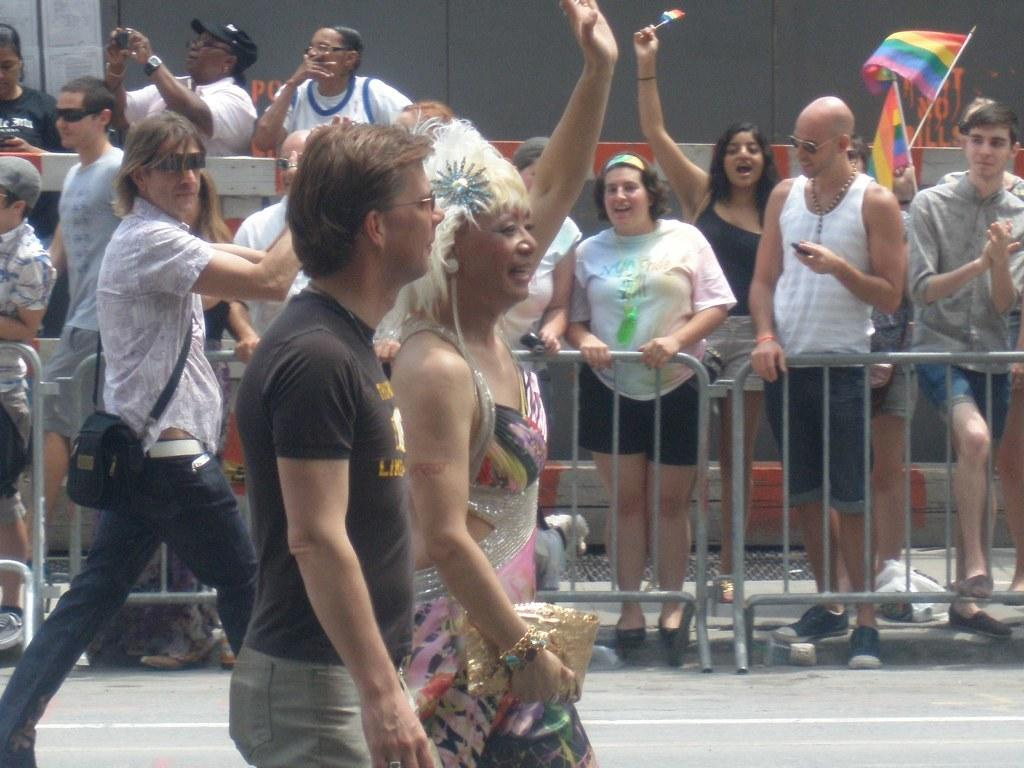What is happening with the group of people in the image? There is a group of people standing beside the road, and some of them are holding objects. Are there any people walking in the image? Yes, there are three people walking on the road. Can you describe the lady in the group? The lady in the group is carrying a handbag. What form of transportation do the people in the image need to reach their destination? The image does not provide information about the people's destination or the form of transportation they might need. 